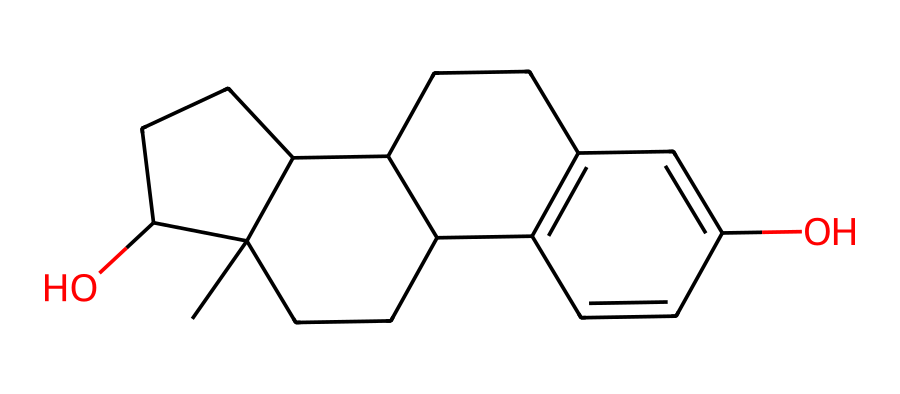What is the molecular formula of this compound? By counting the carbon (C), hydrogen (H), and oxygen (O) atoms in the structure based on the SMILES representation, we identify that there are 18 carbon atoms, 30 hydrogen atoms, and 2 oxygen atoms, leading to the molecular formula C18H30O2.
Answer: C18H30O2 How many rings are present in the structure? Analyzing the chemical structure, we observe that there are four interconnected rings visible, which can be counted by identifying the cyclic portions in the figure derived from the SMILES notation.
Answer: 4 What type of geometric isomerism can occur in this compound? The presence of double bonds in the structure indicates potential for cis-trans isomerism, based on the orientation of the substituents around the double bonds, allowing us to classify the potential isomers accordingly.
Answer: cis-trans How does the presence of OH groups affect the compound's solubility? The OH groups in the compound are hydrophilic due to their ability to form hydrogen bonds with water molecules, which generally increases the solubility of the compound in aqueous environments.
Answer: increases What role can geometric isomers play in hormonal treatments? Geometric isomers may exhibit different biological activities or efficacy due to their spatial arrangement, influencing their interactions with hormonal receptors and subsequently their therapeutic effects.
Answer: different activities Which atom types are involved in forming double bonds within this chemical? By analyzing the molecular structure, we can identify that double bonds are primarily formed between carbon (C) atoms, distinguishing this aspect of the compound.
Answer: carbon 